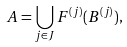<formula> <loc_0><loc_0><loc_500><loc_500>A = \bigcup _ { j \in J } F ^ { ( j ) } ( B ^ { ( j ) } ) ,</formula> 